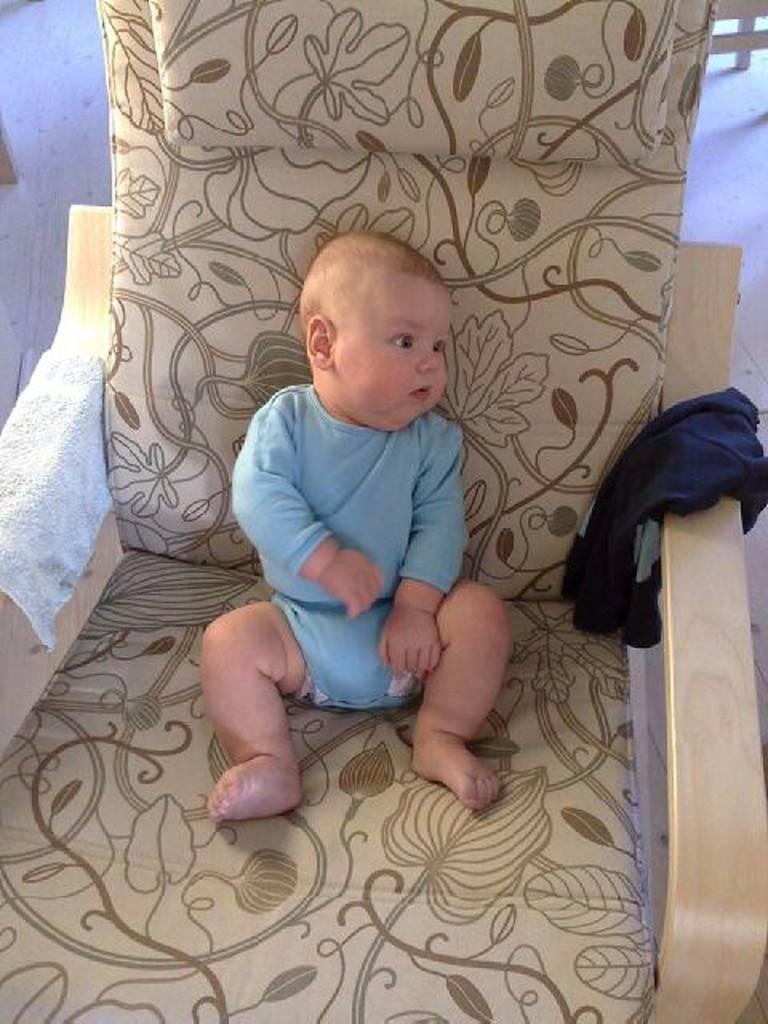Please provide a concise description of this image. There is a baby in light blue color dress, looking at some object and sitting on the chair. On the right hand side of the image, there is a cloth on the chair. On the left hand side of the image, there is a towel on the chair. In the background, there is a floor and some wood item. 